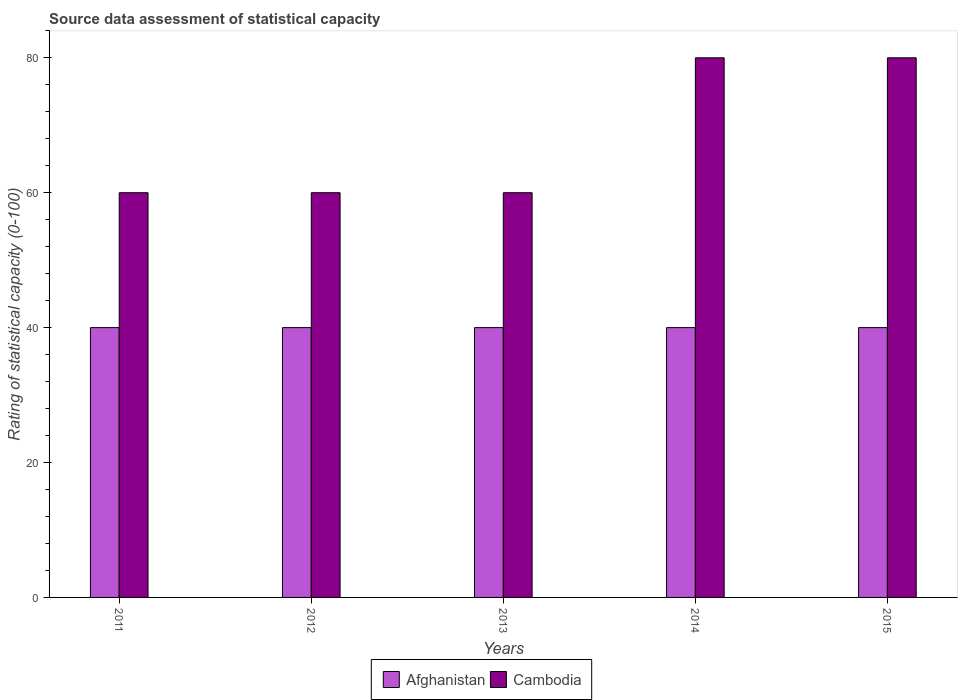How many different coloured bars are there?
Offer a terse response. 2. Are the number of bars per tick equal to the number of legend labels?
Your answer should be very brief. Yes. How many bars are there on the 2nd tick from the left?
Offer a very short reply. 2. What is the label of the 1st group of bars from the left?
Keep it short and to the point. 2011. In how many cases, is the number of bars for a given year not equal to the number of legend labels?
Your answer should be very brief. 0. What is the rating of statistical capacity in Cambodia in 2013?
Keep it short and to the point. 60. Across all years, what is the maximum rating of statistical capacity in Afghanistan?
Offer a very short reply. 40. Across all years, what is the minimum rating of statistical capacity in Cambodia?
Provide a succinct answer. 60. In which year was the rating of statistical capacity in Cambodia maximum?
Your response must be concise. 2014. In which year was the rating of statistical capacity in Cambodia minimum?
Provide a succinct answer. 2011. What is the total rating of statistical capacity in Afghanistan in the graph?
Your answer should be compact. 200. What is the difference between the rating of statistical capacity in Afghanistan in 2012 and that in 2015?
Your response must be concise. 0. What is the difference between the rating of statistical capacity in Cambodia in 2011 and the rating of statistical capacity in Afghanistan in 2015?
Provide a short and direct response. 20. What is the average rating of statistical capacity in Cambodia per year?
Keep it short and to the point. 68. In the year 2014, what is the difference between the rating of statistical capacity in Cambodia and rating of statistical capacity in Afghanistan?
Keep it short and to the point. 40. In how many years, is the rating of statistical capacity in Cambodia greater than 36?
Your answer should be compact. 5. Is the rating of statistical capacity in Cambodia in 2012 less than that in 2014?
Make the answer very short. Yes. What is the difference between the highest and the lowest rating of statistical capacity in Cambodia?
Offer a terse response. 20. In how many years, is the rating of statistical capacity in Afghanistan greater than the average rating of statistical capacity in Afghanistan taken over all years?
Offer a terse response. 0. What does the 1st bar from the left in 2011 represents?
Ensure brevity in your answer.  Afghanistan. What does the 2nd bar from the right in 2012 represents?
Make the answer very short. Afghanistan. Are all the bars in the graph horizontal?
Give a very brief answer. No. Does the graph contain grids?
Your answer should be very brief. No. How are the legend labels stacked?
Your response must be concise. Horizontal. What is the title of the graph?
Make the answer very short. Source data assessment of statistical capacity. What is the label or title of the X-axis?
Offer a very short reply. Years. What is the label or title of the Y-axis?
Provide a succinct answer. Rating of statistical capacity (0-100). What is the Rating of statistical capacity (0-100) in Afghanistan in 2011?
Your answer should be very brief. 40. What is the Rating of statistical capacity (0-100) of Cambodia in 2012?
Your response must be concise. 60. What is the Rating of statistical capacity (0-100) of Afghanistan in 2013?
Your answer should be compact. 40. What is the Rating of statistical capacity (0-100) of Cambodia in 2013?
Provide a short and direct response. 60. What is the Rating of statistical capacity (0-100) of Cambodia in 2014?
Make the answer very short. 80. Across all years, what is the maximum Rating of statistical capacity (0-100) in Cambodia?
Ensure brevity in your answer.  80. Across all years, what is the minimum Rating of statistical capacity (0-100) in Afghanistan?
Offer a very short reply. 40. What is the total Rating of statistical capacity (0-100) in Afghanistan in the graph?
Give a very brief answer. 200. What is the total Rating of statistical capacity (0-100) of Cambodia in the graph?
Give a very brief answer. 340. What is the difference between the Rating of statistical capacity (0-100) of Cambodia in 2011 and that in 2013?
Provide a succinct answer. 0. What is the difference between the Rating of statistical capacity (0-100) in Afghanistan in 2011 and that in 2014?
Your answer should be very brief. 0. What is the difference between the Rating of statistical capacity (0-100) in Cambodia in 2011 and that in 2015?
Your answer should be very brief. -20. What is the difference between the Rating of statistical capacity (0-100) of Afghanistan in 2012 and that in 2013?
Keep it short and to the point. 0. What is the difference between the Rating of statistical capacity (0-100) of Cambodia in 2012 and that in 2014?
Keep it short and to the point. -20. What is the difference between the Rating of statistical capacity (0-100) of Cambodia in 2013 and that in 2014?
Your response must be concise. -20. What is the difference between the Rating of statistical capacity (0-100) of Afghanistan in 2013 and that in 2015?
Offer a terse response. 0. What is the difference between the Rating of statistical capacity (0-100) of Cambodia in 2013 and that in 2015?
Offer a terse response. -20. What is the difference between the Rating of statistical capacity (0-100) of Afghanistan in 2014 and that in 2015?
Give a very brief answer. 0. What is the difference between the Rating of statistical capacity (0-100) in Afghanistan in 2011 and the Rating of statistical capacity (0-100) in Cambodia in 2015?
Provide a succinct answer. -40. What is the difference between the Rating of statistical capacity (0-100) in Afghanistan in 2012 and the Rating of statistical capacity (0-100) in Cambodia in 2014?
Keep it short and to the point. -40. What is the difference between the Rating of statistical capacity (0-100) of Afghanistan in 2012 and the Rating of statistical capacity (0-100) of Cambodia in 2015?
Offer a terse response. -40. What is the average Rating of statistical capacity (0-100) in Cambodia per year?
Keep it short and to the point. 68. In the year 2012, what is the difference between the Rating of statistical capacity (0-100) in Afghanistan and Rating of statistical capacity (0-100) in Cambodia?
Your response must be concise. -20. In the year 2013, what is the difference between the Rating of statistical capacity (0-100) in Afghanistan and Rating of statistical capacity (0-100) in Cambodia?
Provide a short and direct response. -20. In the year 2015, what is the difference between the Rating of statistical capacity (0-100) in Afghanistan and Rating of statistical capacity (0-100) in Cambodia?
Your answer should be compact. -40. What is the ratio of the Rating of statistical capacity (0-100) of Afghanistan in 2011 to that in 2012?
Your answer should be very brief. 1. What is the ratio of the Rating of statistical capacity (0-100) of Afghanistan in 2011 to that in 2013?
Your answer should be very brief. 1. What is the ratio of the Rating of statistical capacity (0-100) of Afghanistan in 2011 to that in 2014?
Offer a terse response. 1. What is the ratio of the Rating of statistical capacity (0-100) in Afghanistan in 2012 to that in 2013?
Give a very brief answer. 1. What is the ratio of the Rating of statistical capacity (0-100) of Afghanistan in 2012 to that in 2014?
Offer a terse response. 1. What is the ratio of the Rating of statistical capacity (0-100) in Afghanistan in 2012 to that in 2015?
Give a very brief answer. 1. What is the ratio of the Rating of statistical capacity (0-100) of Cambodia in 2013 to that in 2014?
Provide a short and direct response. 0.75. What is the ratio of the Rating of statistical capacity (0-100) of Cambodia in 2013 to that in 2015?
Provide a short and direct response. 0.75. What is the ratio of the Rating of statistical capacity (0-100) in Afghanistan in 2014 to that in 2015?
Keep it short and to the point. 1. What is the ratio of the Rating of statistical capacity (0-100) of Cambodia in 2014 to that in 2015?
Your response must be concise. 1. What is the difference between the highest and the lowest Rating of statistical capacity (0-100) in Afghanistan?
Your answer should be very brief. 0. What is the difference between the highest and the lowest Rating of statistical capacity (0-100) in Cambodia?
Make the answer very short. 20. 